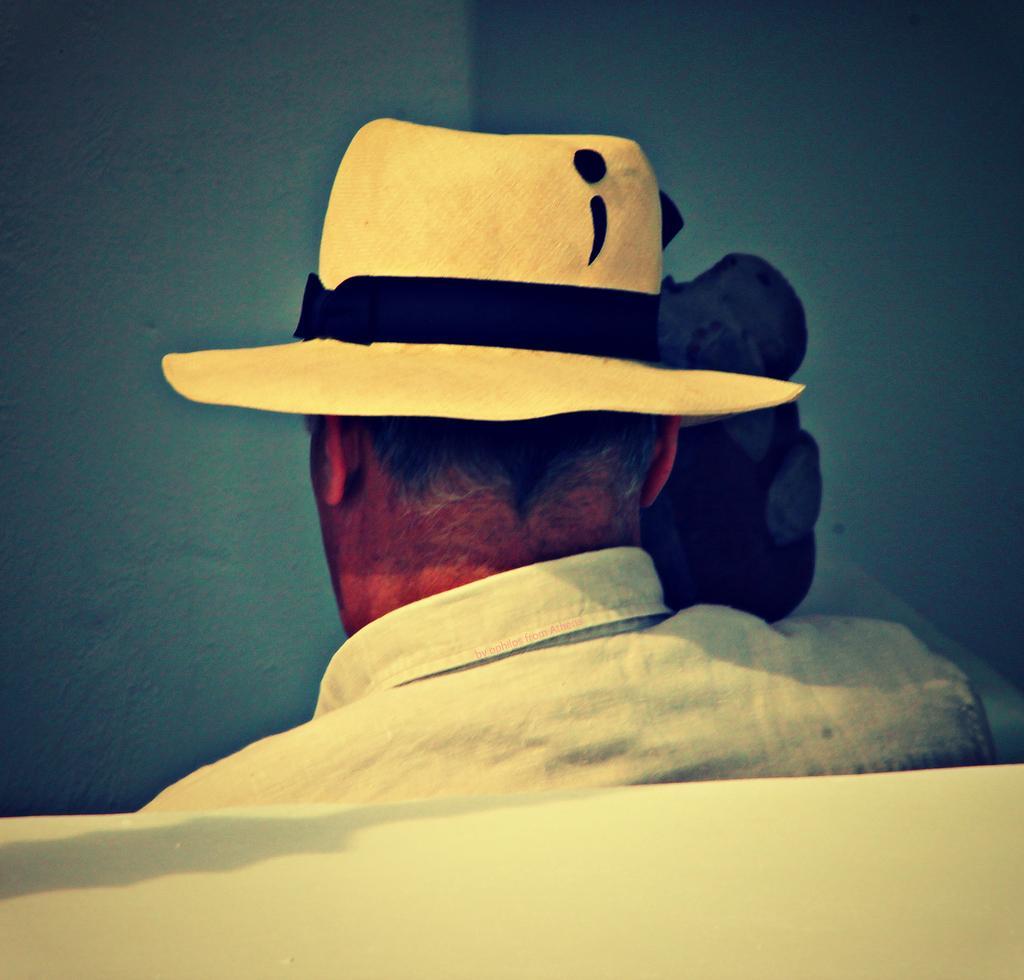Please provide a concise description of this image. This image consists of a person. He is wearing a white shirt. He is wearing a hat. 